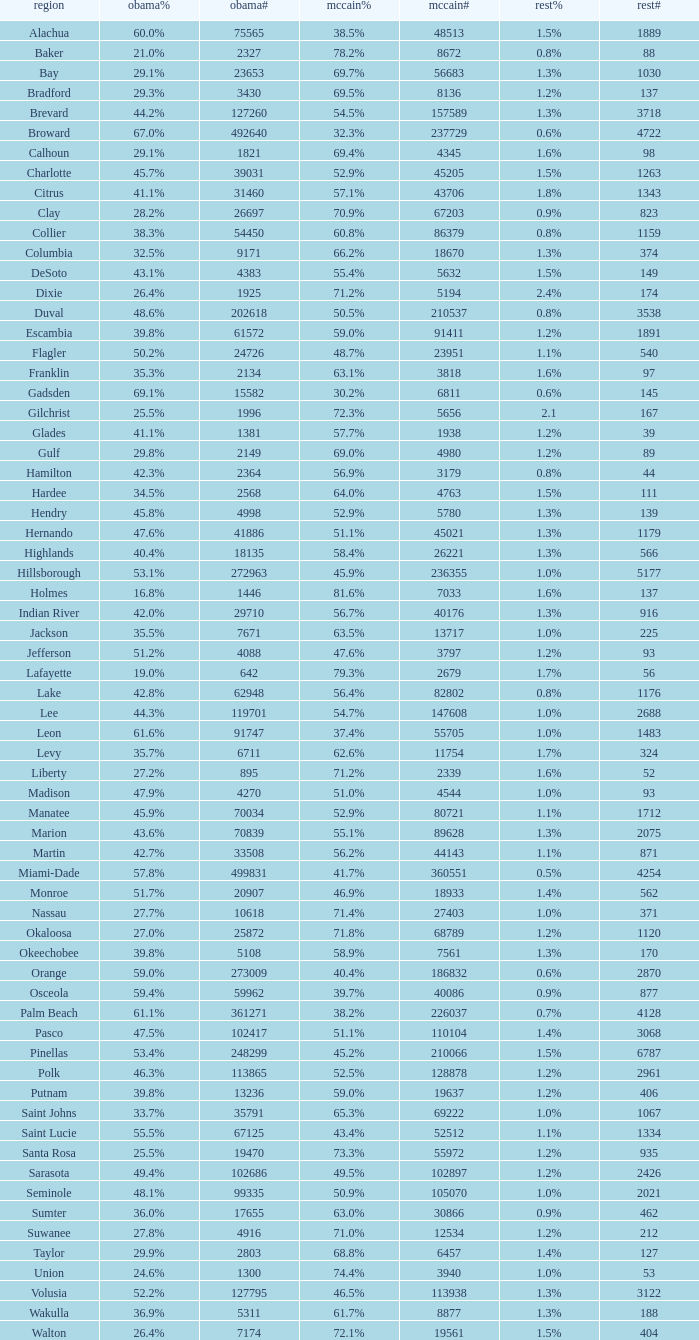How many numbers were recorded under Obama when he had 29.9% voters? 1.0. 